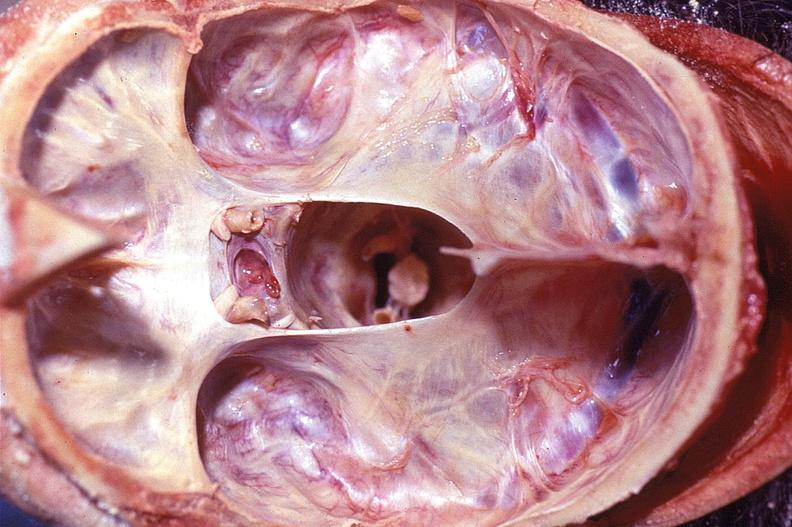s pierre robin sndrome present?
Answer the question using a single word or phrase. No 